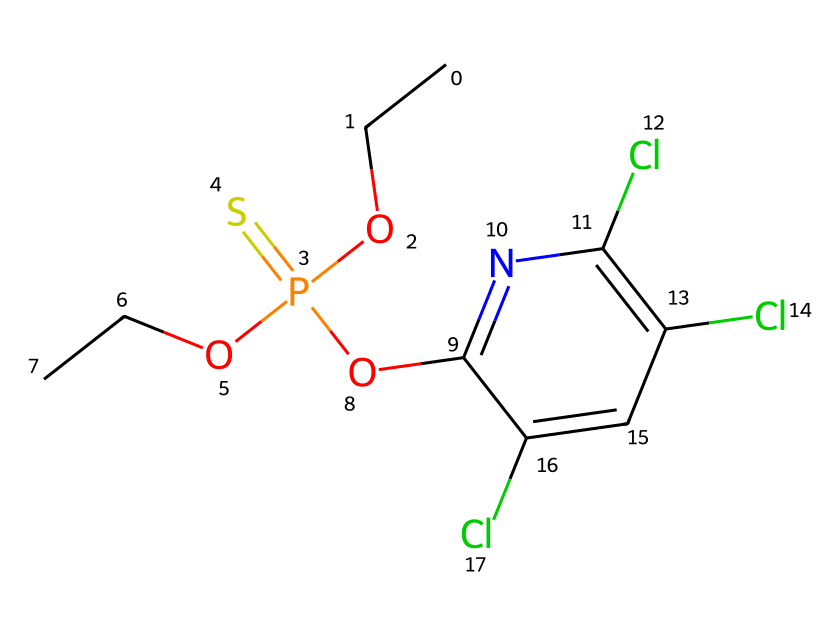What is the common name of this chemical? The SMILES representation indicates the chemical structure contains the group associated with organophosphates. This specific combination of elements corresponds to chlorpyrifos, a well-known organophosphate insecticide.
Answer: chlorpyrifos How many chlorine atoms are present in the structure? Analyzing the SMILES representation, I can identify three occurrences of "Cl," indicating three chlorine atoms incorporated within the molecular structure.
Answer: 3 What is the number of carbon atoms in chlorpyrifos? The SMILES representation contains several occurrences of "C" for carbon atoms. By counting each carbon-specific entry, we see there are six carbon atoms present in the chlorpyrifos structure.
Answer: 6 What functional group is present in chlorpyrifos? In the structure, the presence of the phosphorus atom connected to oxygen and sulfur suggests that chlorpyrifos has a phosphorothioate functional group. This classification highlights its organophosphate characteristics.
Answer: phosphorothioate What type of compound is chlorpyrifos primarily classified as? Based on the presence of organophosphate functionality indicated by the arrangement of atoms, chlorpyrifos is classified primarily as an insecticide. Its structure reveals its intended agricultural use.
Answer: insecticide Why is chlorpyrifos considered hazardous? The combination of chlorine atoms and the organophosphate nature of chlorpyrifos leads to its classification as a hazardous chemical. These elements contribute to neurotoxic effects in non-target organisms and potential human health risks.
Answer: neurotoxic What is the total number of oxygen atoms in this molecule? Counting the occurrences of "O" in the SMILES representation shows that there are two oxygen atoms explicitly indicated in the chlorpyrifos structure. These atoms contribute to its biological activity and functionality.
Answer: 2 